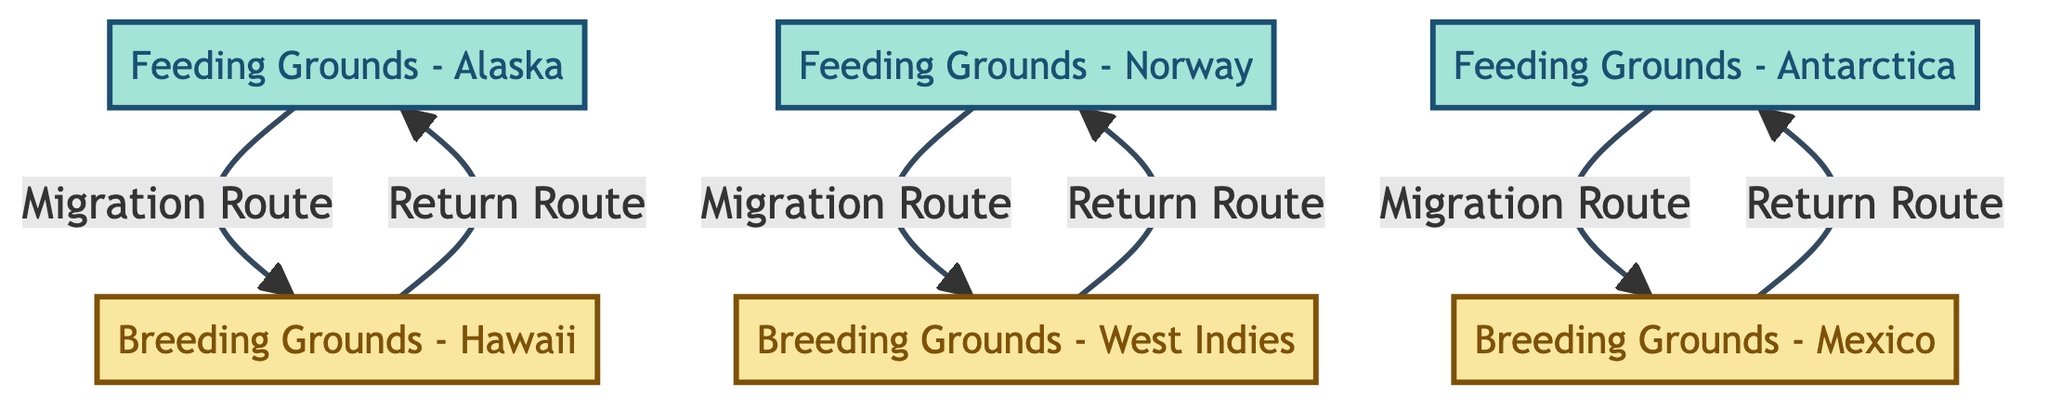What are the breeding grounds for humpback whales listed in the diagram? The diagram identifies three breeding grounds for humpback whales: Hawaii, Mexico, and West Indies. Each of these locations is described as a warm water area where whales migrate for breeding and calving.
Answer: Hawaii, Mexico, West Indies How many feeding grounds are there? The diagram includes four feeding grounds: Alaska, Antarctica, and Norway. Counting each listed node confirms the total number of feeding grounds shown in the visual representation.
Answer: 4 What migration route connects feeding grounds in Alaska to breeding grounds? The diagram indicates a specific migration route labeled "Migration Route - Alaska to Hawaii" that connects the feeding ground in Alaska to the breeding ground in Hawaii. The directed edge visually demonstrates the pathway taken by the whales during migration.
Answer: Migration Route - Alaska to Hawaii Which breeding ground has a return route connecting to the feeding grounds in Antarctica? The diagram shows that the breeding grounds in Mexico have a return route connecting back to the feeding grounds in Antarctica. The directed edge indicates the reverse migration after breeding takes place.
Answer: Breeding Grounds - Mexico How many total edges are in the diagram? The diagram features six directed edges that denote the migration and return routes between the nodes. By counting each edge displayed, we confirm the total number of edges represented in the directed graph.
Answer: 6 What is the return route from breeding grounds in West Indies? The return route from the breeding grounds in West Indies leads to the feeding grounds in Norway. This route is specifically labeled "Return Route - West Indies to Norway" within the diagram, indicating the migration pathway after breeding has occurred.
Answer: Return Route - West Indies to Norway Which feeding ground is served by a migration route from Antarctica? The diagram shows that the feeding ground in Mexico is connected to the feeding grounds in Antarctica through the migration route labeled "Migration Route - Antarctica to Mexico." This indicates that some whales migrate from the Antarctic feeding grounds to breed in Mexico.
Answer: Feeding Grounds - Mexico How many breeding grounds are connected to the feeding grounds in Norway? The feeding grounds in Norway are connected to one specific breeding ground, which is the West Indies. This is illustrated in the diagram by the directed edge labeled "Migration Route - Norway to West Indies."
Answer: 1 